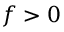Convert formula to latex. <formula><loc_0><loc_0><loc_500><loc_500>f > 0</formula> 